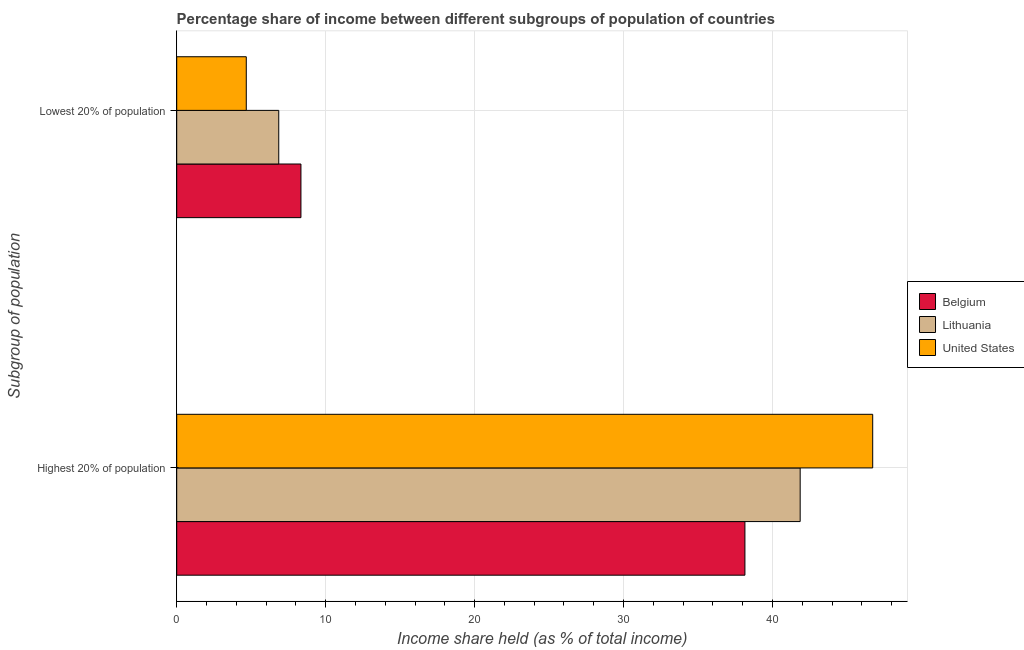How many different coloured bars are there?
Make the answer very short. 3. How many groups of bars are there?
Provide a succinct answer. 2. Are the number of bars per tick equal to the number of legend labels?
Make the answer very short. Yes. What is the label of the 2nd group of bars from the top?
Provide a short and direct response. Highest 20% of population. What is the income share held by highest 20% of the population in Belgium?
Give a very brief answer. 38.15. Across all countries, what is the maximum income share held by lowest 20% of the population?
Make the answer very short. 8.34. Across all countries, what is the minimum income share held by highest 20% of the population?
Make the answer very short. 38.15. What is the total income share held by lowest 20% of the population in the graph?
Give a very brief answer. 19.86. What is the difference between the income share held by lowest 20% of the population in Lithuania and that in Belgium?
Your response must be concise. -1.49. What is the difference between the income share held by highest 20% of the population in Lithuania and the income share held by lowest 20% of the population in Belgium?
Your response must be concise. 33.52. What is the average income share held by lowest 20% of the population per country?
Your answer should be very brief. 6.62. What is the difference between the income share held by highest 20% of the population and income share held by lowest 20% of the population in Lithuania?
Offer a very short reply. 35.01. What is the ratio of the income share held by highest 20% of the population in United States to that in Belgium?
Make the answer very short. 1.22. What does the 1st bar from the bottom in Lowest 20% of population represents?
Offer a very short reply. Belgium. How many bars are there?
Offer a very short reply. 6. How many countries are there in the graph?
Offer a terse response. 3. What is the difference between two consecutive major ticks on the X-axis?
Provide a succinct answer. 10. Does the graph contain any zero values?
Provide a short and direct response. No. Does the graph contain grids?
Offer a very short reply. Yes. Where does the legend appear in the graph?
Your response must be concise. Center right. What is the title of the graph?
Your response must be concise. Percentage share of income between different subgroups of population of countries. Does "Angola" appear as one of the legend labels in the graph?
Keep it short and to the point. No. What is the label or title of the X-axis?
Your answer should be very brief. Income share held (as % of total income). What is the label or title of the Y-axis?
Keep it short and to the point. Subgroup of population. What is the Income share held (as % of total income) in Belgium in Highest 20% of population?
Keep it short and to the point. 38.15. What is the Income share held (as % of total income) of Lithuania in Highest 20% of population?
Give a very brief answer. 41.86. What is the Income share held (as % of total income) of United States in Highest 20% of population?
Ensure brevity in your answer.  46.73. What is the Income share held (as % of total income) of Belgium in Lowest 20% of population?
Offer a terse response. 8.34. What is the Income share held (as % of total income) in Lithuania in Lowest 20% of population?
Make the answer very short. 6.85. What is the Income share held (as % of total income) in United States in Lowest 20% of population?
Your answer should be very brief. 4.67. Across all Subgroup of population, what is the maximum Income share held (as % of total income) in Belgium?
Offer a terse response. 38.15. Across all Subgroup of population, what is the maximum Income share held (as % of total income) of Lithuania?
Give a very brief answer. 41.86. Across all Subgroup of population, what is the maximum Income share held (as % of total income) of United States?
Ensure brevity in your answer.  46.73. Across all Subgroup of population, what is the minimum Income share held (as % of total income) in Belgium?
Offer a very short reply. 8.34. Across all Subgroup of population, what is the minimum Income share held (as % of total income) in Lithuania?
Make the answer very short. 6.85. Across all Subgroup of population, what is the minimum Income share held (as % of total income) in United States?
Your answer should be compact. 4.67. What is the total Income share held (as % of total income) in Belgium in the graph?
Your answer should be compact. 46.49. What is the total Income share held (as % of total income) in Lithuania in the graph?
Provide a short and direct response. 48.71. What is the total Income share held (as % of total income) in United States in the graph?
Your answer should be compact. 51.4. What is the difference between the Income share held (as % of total income) in Belgium in Highest 20% of population and that in Lowest 20% of population?
Your answer should be very brief. 29.81. What is the difference between the Income share held (as % of total income) of Lithuania in Highest 20% of population and that in Lowest 20% of population?
Provide a short and direct response. 35.01. What is the difference between the Income share held (as % of total income) of United States in Highest 20% of population and that in Lowest 20% of population?
Offer a terse response. 42.06. What is the difference between the Income share held (as % of total income) of Belgium in Highest 20% of population and the Income share held (as % of total income) of Lithuania in Lowest 20% of population?
Give a very brief answer. 31.3. What is the difference between the Income share held (as % of total income) of Belgium in Highest 20% of population and the Income share held (as % of total income) of United States in Lowest 20% of population?
Make the answer very short. 33.48. What is the difference between the Income share held (as % of total income) of Lithuania in Highest 20% of population and the Income share held (as % of total income) of United States in Lowest 20% of population?
Make the answer very short. 37.19. What is the average Income share held (as % of total income) in Belgium per Subgroup of population?
Your response must be concise. 23.25. What is the average Income share held (as % of total income) in Lithuania per Subgroup of population?
Your answer should be compact. 24.36. What is the average Income share held (as % of total income) in United States per Subgroup of population?
Make the answer very short. 25.7. What is the difference between the Income share held (as % of total income) of Belgium and Income share held (as % of total income) of Lithuania in Highest 20% of population?
Your answer should be very brief. -3.71. What is the difference between the Income share held (as % of total income) of Belgium and Income share held (as % of total income) of United States in Highest 20% of population?
Your answer should be very brief. -8.58. What is the difference between the Income share held (as % of total income) in Lithuania and Income share held (as % of total income) in United States in Highest 20% of population?
Ensure brevity in your answer.  -4.87. What is the difference between the Income share held (as % of total income) of Belgium and Income share held (as % of total income) of Lithuania in Lowest 20% of population?
Make the answer very short. 1.49. What is the difference between the Income share held (as % of total income) of Belgium and Income share held (as % of total income) of United States in Lowest 20% of population?
Offer a terse response. 3.67. What is the difference between the Income share held (as % of total income) in Lithuania and Income share held (as % of total income) in United States in Lowest 20% of population?
Ensure brevity in your answer.  2.18. What is the ratio of the Income share held (as % of total income) of Belgium in Highest 20% of population to that in Lowest 20% of population?
Your answer should be very brief. 4.57. What is the ratio of the Income share held (as % of total income) in Lithuania in Highest 20% of population to that in Lowest 20% of population?
Ensure brevity in your answer.  6.11. What is the ratio of the Income share held (as % of total income) of United States in Highest 20% of population to that in Lowest 20% of population?
Provide a short and direct response. 10.01. What is the difference between the highest and the second highest Income share held (as % of total income) of Belgium?
Ensure brevity in your answer.  29.81. What is the difference between the highest and the second highest Income share held (as % of total income) of Lithuania?
Make the answer very short. 35.01. What is the difference between the highest and the second highest Income share held (as % of total income) in United States?
Offer a terse response. 42.06. What is the difference between the highest and the lowest Income share held (as % of total income) in Belgium?
Ensure brevity in your answer.  29.81. What is the difference between the highest and the lowest Income share held (as % of total income) of Lithuania?
Your answer should be very brief. 35.01. What is the difference between the highest and the lowest Income share held (as % of total income) of United States?
Your answer should be compact. 42.06. 